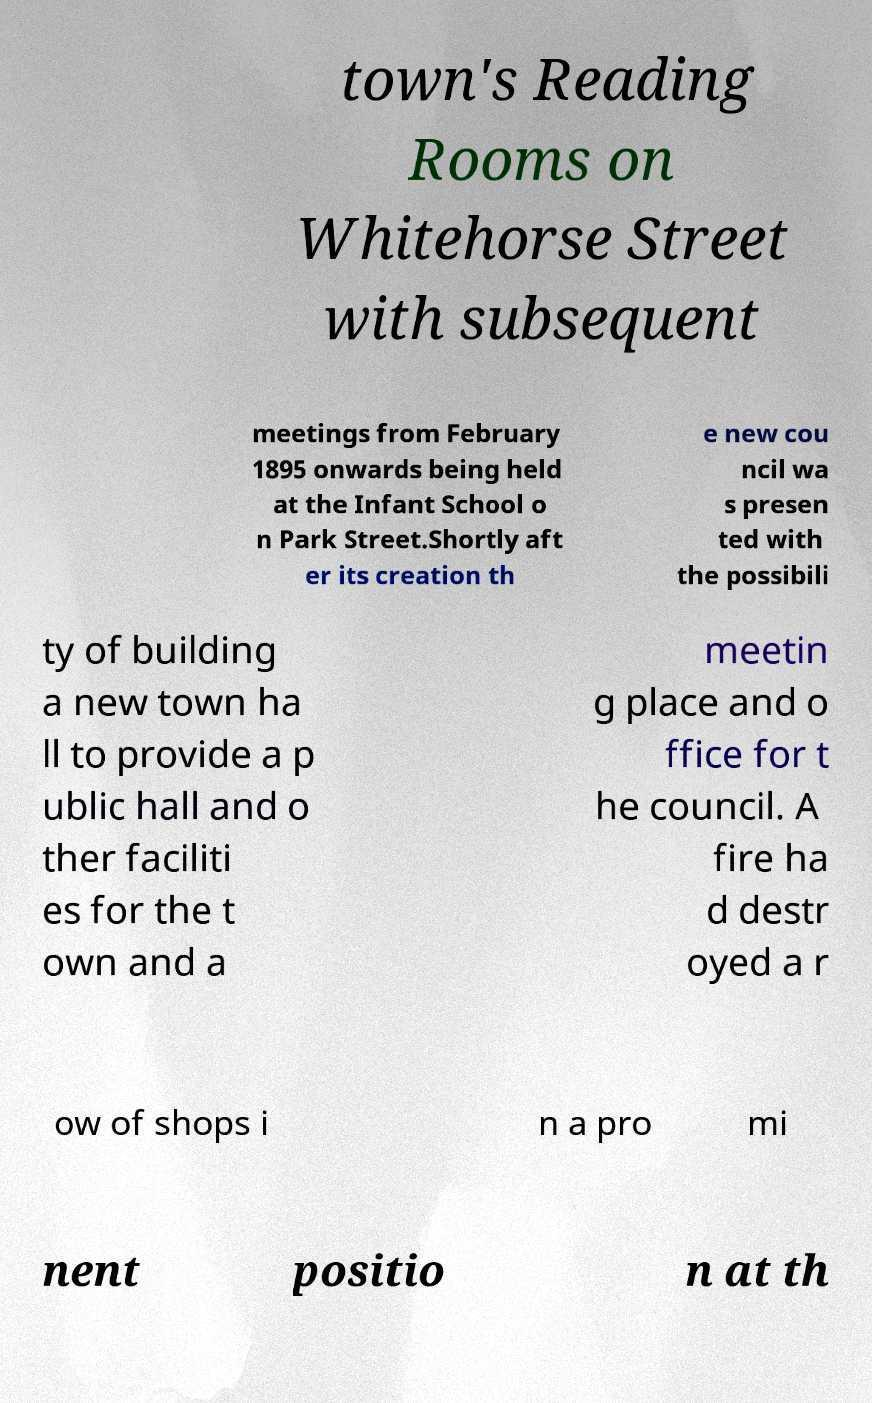Please identify and transcribe the text found in this image. town's Reading Rooms on Whitehorse Street with subsequent meetings from February 1895 onwards being held at the Infant School o n Park Street.Shortly aft er its creation th e new cou ncil wa s presen ted with the possibili ty of building a new town ha ll to provide a p ublic hall and o ther faciliti es for the t own and a meetin g place and o ffice for t he council. A fire ha d destr oyed a r ow of shops i n a pro mi nent positio n at th 